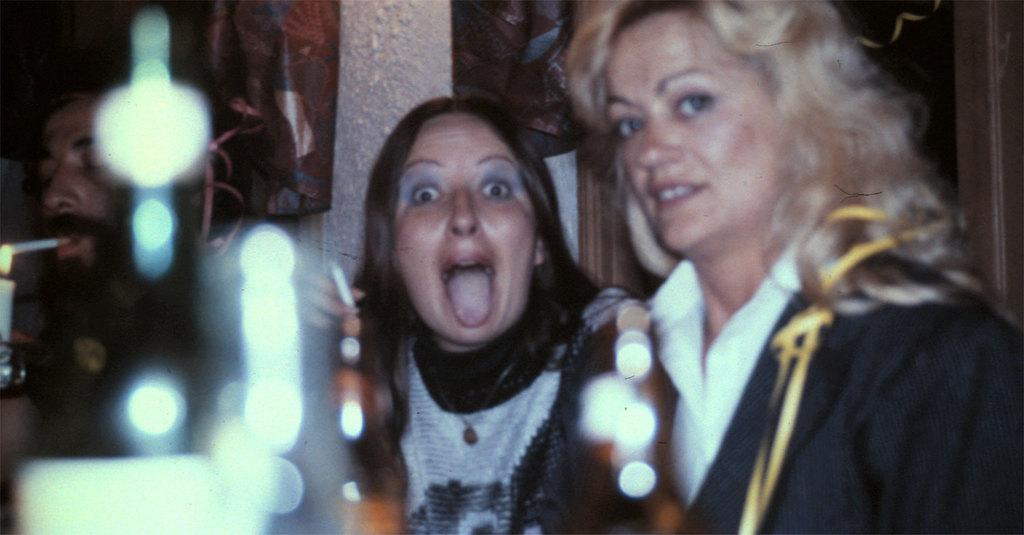How many people are in the front of the image? There are two women and a man in the front of the image. What can be seen on the left side of the image? There is a candle on the left side of the image. What is the man doing in the image? The man is smoking a cigar. What is the lighting condition in the background of the image? The background of the image is dark. How many spiders are crawling on the stove in the image? There is no stove or spiders present in the image. What type of change is the man holding in the image? There is no change visible in the image; the man is smoking a cigar. 